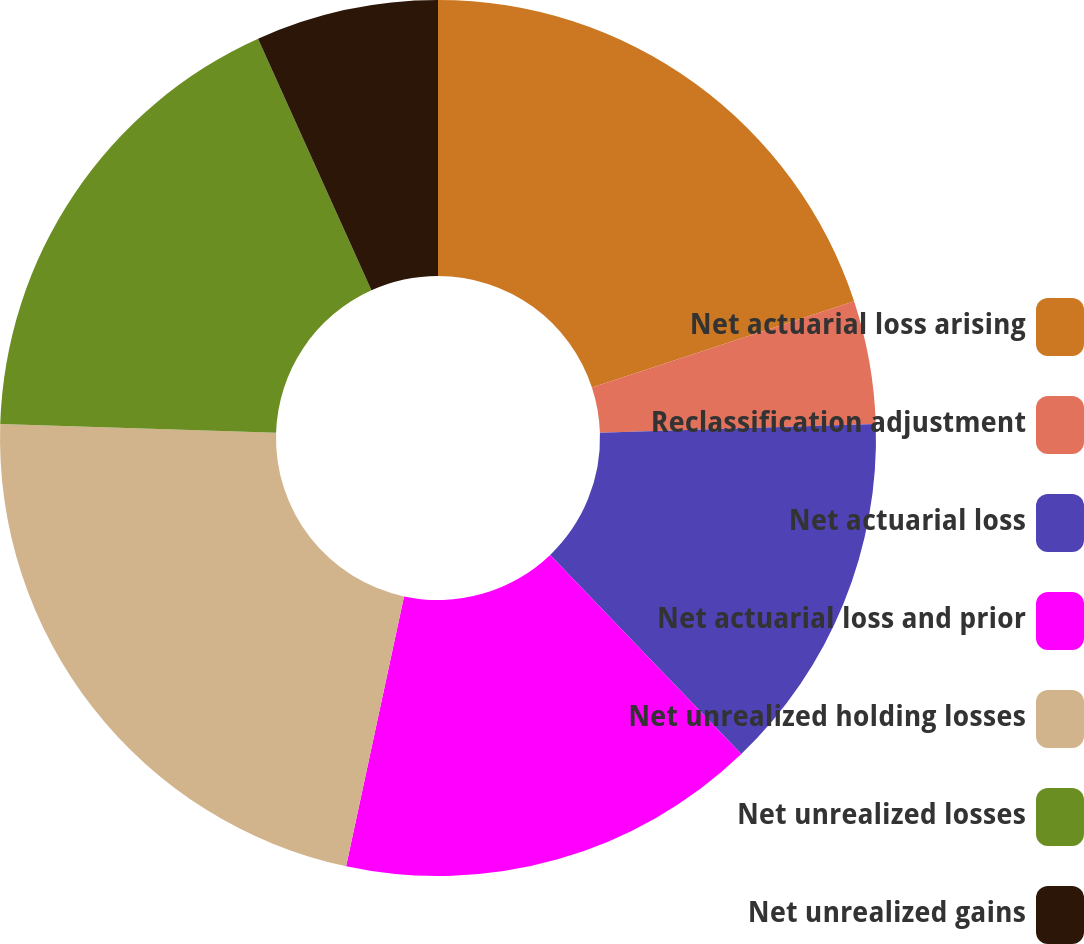<chart> <loc_0><loc_0><loc_500><loc_500><pie_chart><fcel>Net actuarial loss arising<fcel>Reclassification adjustment<fcel>Net actuarial loss<fcel>Net actuarial loss and prior<fcel>Net unrealized holding losses<fcel>Net unrealized losses<fcel>Net unrealized gains<nl><fcel>19.95%<fcel>4.54%<fcel>13.34%<fcel>15.54%<fcel>22.15%<fcel>17.75%<fcel>6.74%<nl></chart> 